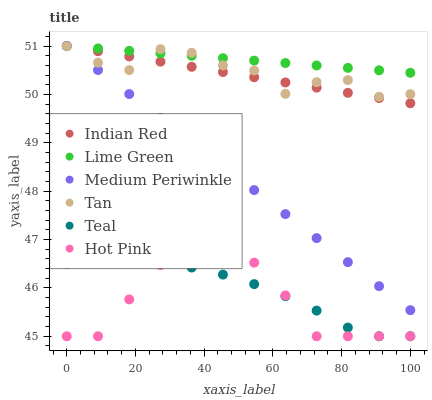Does Hot Pink have the minimum area under the curve?
Answer yes or no. Yes. Does Lime Green have the maximum area under the curve?
Answer yes or no. Yes. Does Medium Periwinkle have the minimum area under the curve?
Answer yes or no. No. Does Medium Periwinkle have the maximum area under the curve?
Answer yes or no. No. Is Indian Red the smoothest?
Answer yes or no. Yes. Is Tan the roughest?
Answer yes or no. Yes. Is Hot Pink the smoothest?
Answer yes or no. No. Is Hot Pink the roughest?
Answer yes or no. No. Does Hot Pink have the lowest value?
Answer yes or no. Yes. Does Medium Periwinkle have the lowest value?
Answer yes or no. No. Does Lime Green have the highest value?
Answer yes or no. Yes. Does Hot Pink have the highest value?
Answer yes or no. No. Is Teal less than Lime Green?
Answer yes or no. Yes. Is Indian Red greater than Teal?
Answer yes or no. Yes. Does Tan intersect Medium Periwinkle?
Answer yes or no. Yes. Is Tan less than Medium Periwinkle?
Answer yes or no. No. Is Tan greater than Medium Periwinkle?
Answer yes or no. No. Does Teal intersect Lime Green?
Answer yes or no. No. 